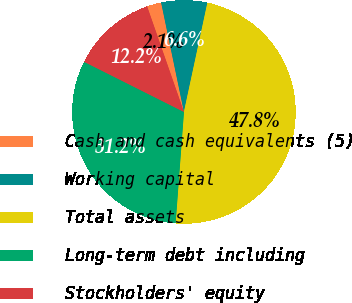<chart> <loc_0><loc_0><loc_500><loc_500><pie_chart><fcel>Cash and cash equivalents (5)<fcel>Working capital<fcel>Total assets<fcel>Long-term debt including<fcel>Stockholders' equity<nl><fcel>2.07%<fcel>6.64%<fcel>47.82%<fcel>31.22%<fcel>12.25%<nl></chart> 